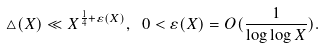Convert formula to latex. <formula><loc_0><loc_0><loc_500><loc_500>\triangle ( X ) \ll X ^ { \frac { 1 } { 4 } + \varepsilon ( X ) } , \ 0 < \varepsilon ( X ) = O ( \frac { 1 } { \log \log X } ) .</formula> 